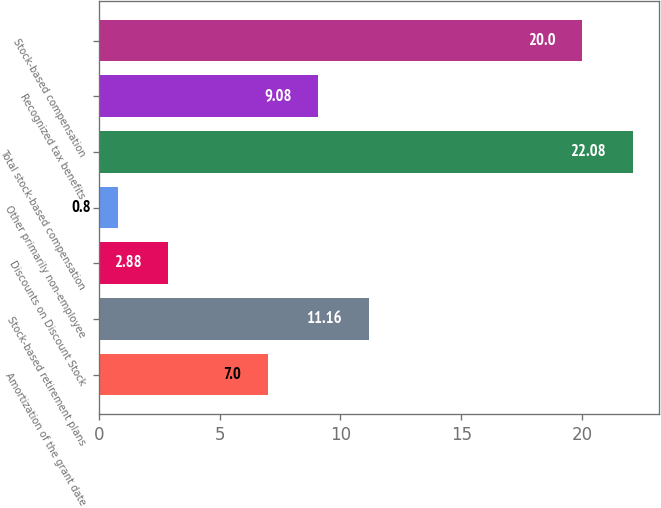<chart> <loc_0><loc_0><loc_500><loc_500><bar_chart><fcel>Amortization of the grant date<fcel>Stock-based retirement plans<fcel>Discounts on Discount Stock<fcel>Other primarily non-employee<fcel>Total stock-based compensation<fcel>Recognized tax benefits<fcel>Stock-based compensation<nl><fcel>7<fcel>11.16<fcel>2.88<fcel>0.8<fcel>22.08<fcel>9.08<fcel>20<nl></chart> 